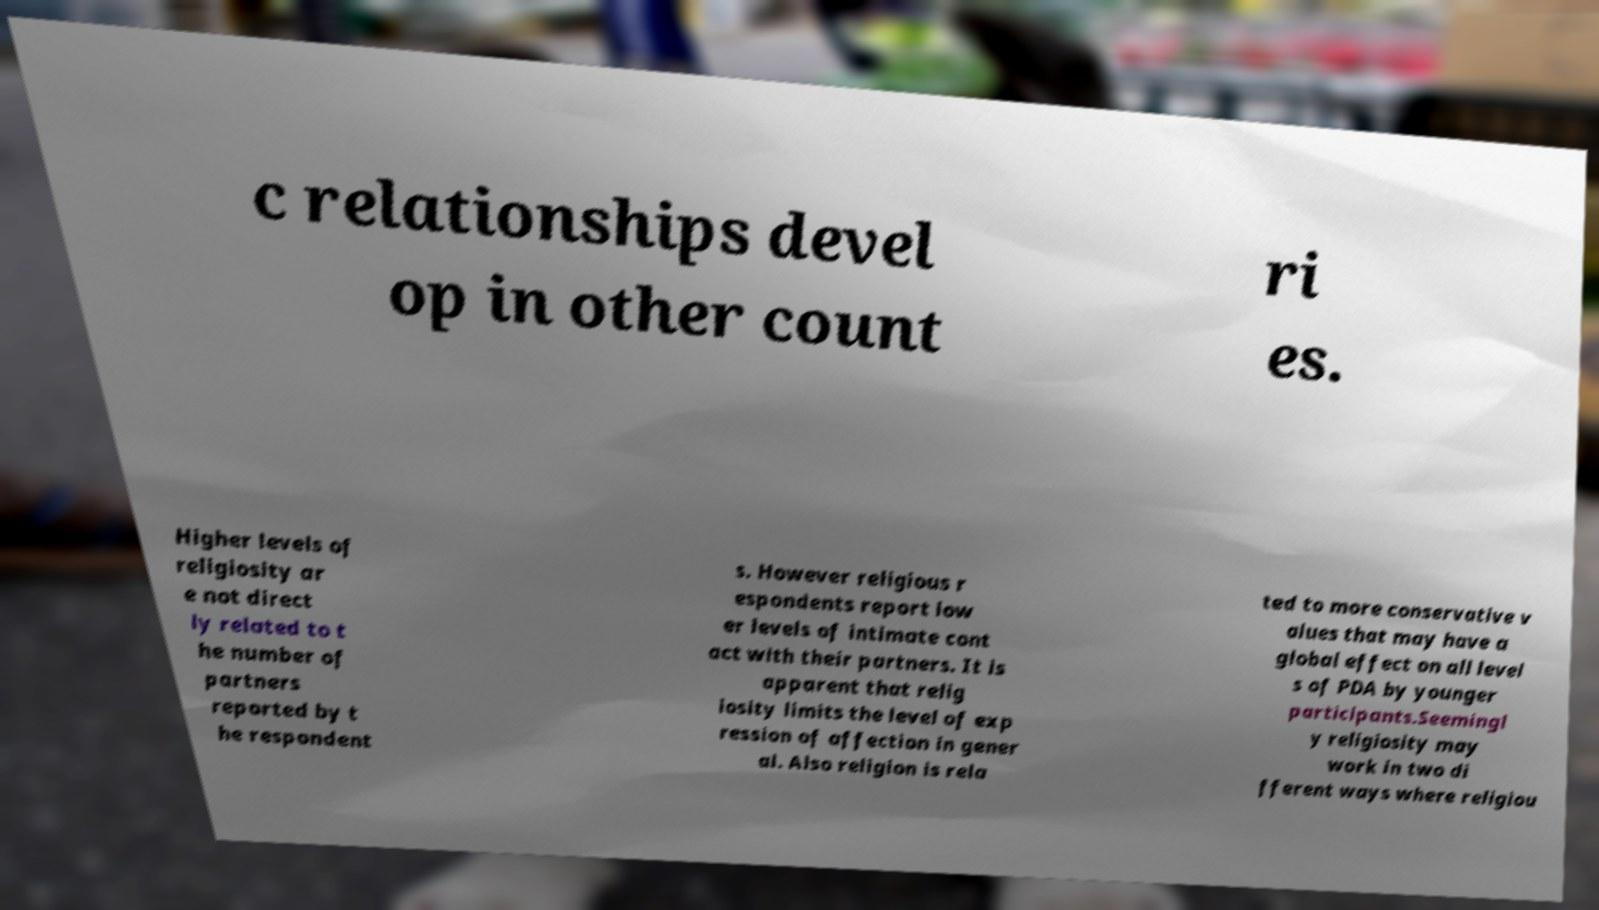What messages or text are displayed in this image? I need them in a readable, typed format. c relationships devel op in other count ri es. Higher levels of religiosity ar e not direct ly related to t he number of partners reported by t he respondent s. However religious r espondents report low er levels of intimate cont act with their partners. It is apparent that relig iosity limits the level of exp ression of affection in gener al. Also religion is rela ted to more conservative v alues that may have a global effect on all level s of PDA by younger participants.Seemingl y religiosity may work in two di fferent ways where religiou 